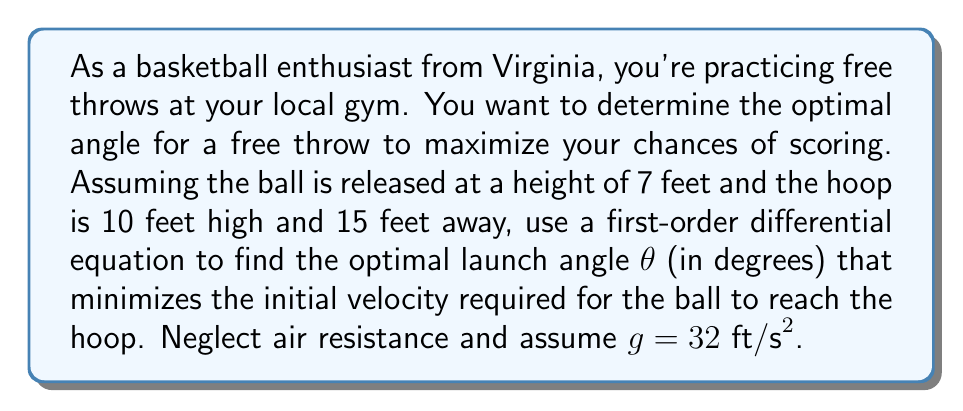Help me with this question. To solve this problem, we'll use the following steps:

1) First, let's set up our coordinate system. Let x be the horizontal distance and y be the vertical distance.

2) The equations of motion for a projectile are:

   $$x = v_0 \cos(\theta) t$$
   $$y = 7 + v_0 \sin(\theta) t - \frac{1}{2}gt^2$$

   where $v_0$ is the initial velocity, $\theta$ is the launch angle, and t is time.

3) We know that when the ball reaches the hoop, x = 15 and y = 10. Substituting these into our equations:

   $$15 = v_0 \cos(\theta) t$$
   $$10 = 7 + v_0 \sin(\theta) t - 16t^2$$

4) From the first equation, we can express t in terms of $v_0$ and $\theta$:

   $$t = \frac{15}{v_0 \cos(\theta)}$$

5) Substituting this into the second equation:

   $$10 = 7 + v_0 \sin(\theta) \frac{15}{v_0 \cos(\theta)} - 16(\frac{15}{v_0 \cos(\theta)})^2$$

6) Simplifying:

   $$3 = 15 \tan(\theta) - \frac{3600}{v_0^2 \cos^2(\theta)}$$

7) Rearranging to express $v_0$ in terms of $\theta$:

   $$v_0^2 = \frac{3600}{3\cos^2(\theta) + 15\sin(\theta)\cos^2(\theta)}$$

8) To find the minimum $v_0$, we need to find where the derivative of $v_0$ with respect to $\theta$ is zero. However, it's easier to minimize $v_0^2$ instead, which will occur at the same angle.

9) Taking the derivative and setting it to zero:

   $$\frac{d}{d\theta}(v_0^2) = \frac{d}{d\theta}(\frac{3600}{3\cos^2(\theta) + 15\sin(\theta)\cos^2(\theta)}) = 0$$

10) After differentiating and simplifying, we get:

    $$15\sin^3(\theta) - 9\cos(\theta)\sin(\theta) = 0$$

11) Factoring out $\sin(\theta)$:

    $$\sin(\theta)(15\sin^2(\theta) - 9\cos(\theta)) = 0$$

12) The solution $\sin(\theta) = 0$ doesn't work for our scenario, so we solve:

    $$15\sin^2(\theta) - 9\cos(\theta) = 0$$

13) Using the identity $\sin^2(\theta) = 1 - \cos^2(\theta)$:

    $$15(1 - \cos^2(\theta)) - 9\cos(\theta) = 0$$

14) This is a quadratic in $\cos(\theta)$. Solving it gives:

    $$\cos(\theta) = \frac{3}{5}$$

15) Therefore, the optimal angle is:

    $$\theta = \arccos(\frac{3}{5}) \approx 53.13°$$
Answer: The optimal launch angle for the free throw is approximately 53.13°. 